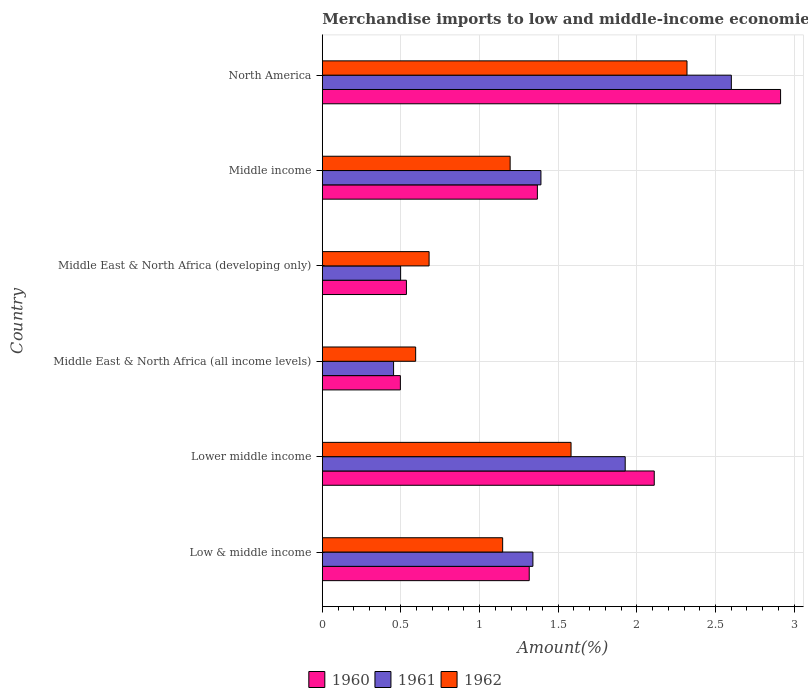How many different coloured bars are there?
Keep it short and to the point. 3. How many groups of bars are there?
Your response must be concise. 6. How many bars are there on the 6th tick from the top?
Keep it short and to the point. 3. How many bars are there on the 2nd tick from the bottom?
Keep it short and to the point. 3. What is the label of the 5th group of bars from the top?
Your answer should be very brief. Lower middle income. What is the percentage of amount earned from merchandise imports in 1960 in Low & middle income?
Make the answer very short. 1.32. Across all countries, what is the maximum percentage of amount earned from merchandise imports in 1961?
Keep it short and to the point. 2.6. Across all countries, what is the minimum percentage of amount earned from merchandise imports in 1961?
Provide a succinct answer. 0.45. In which country was the percentage of amount earned from merchandise imports in 1961 minimum?
Your answer should be very brief. Middle East & North Africa (all income levels). What is the total percentage of amount earned from merchandise imports in 1960 in the graph?
Offer a terse response. 8.74. What is the difference between the percentage of amount earned from merchandise imports in 1960 in Low & middle income and that in Lower middle income?
Keep it short and to the point. -0.79. What is the difference between the percentage of amount earned from merchandise imports in 1962 in Lower middle income and the percentage of amount earned from merchandise imports in 1961 in Low & middle income?
Offer a very short reply. 0.24. What is the average percentage of amount earned from merchandise imports in 1960 per country?
Provide a succinct answer. 1.46. What is the difference between the percentage of amount earned from merchandise imports in 1962 and percentage of amount earned from merchandise imports in 1961 in Middle East & North Africa (developing only)?
Give a very brief answer. 0.18. In how many countries, is the percentage of amount earned from merchandise imports in 1962 greater than 0.6 %?
Keep it short and to the point. 5. What is the ratio of the percentage of amount earned from merchandise imports in 1962 in Lower middle income to that in Middle East & North Africa (all income levels)?
Provide a succinct answer. 2.67. What is the difference between the highest and the second highest percentage of amount earned from merchandise imports in 1960?
Your answer should be very brief. 0.8. What is the difference between the highest and the lowest percentage of amount earned from merchandise imports in 1961?
Keep it short and to the point. 2.15. In how many countries, is the percentage of amount earned from merchandise imports in 1960 greater than the average percentage of amount earned from merchandise imports in 1960 taken over all countries?
Your answer should be compact. 2. Is the sum of the percentage of amount earned from merchandise imports in 1961 in Low & middle income and Lower middle income greater than the maximum percentage of amount earned from merchandise imports in 1960 across all countries?
Ensure brevity in your answer.  Yes. Are all the bars in the graph horizontal?
Give a very brief answer. Yes. Where does the legend appear in the graph?
Ensure brevity in your answer.  Bottom center. How are the legend labels stacked?
Give a very brief answer. Horizontal. What is the title of the graph?
Offer a terse response. Merchandise imports to low and middle-income economies in East Asia & Pacific. What is the label or title of the X-axis?
Your response must be concise. Amount(%). What is the label or title of the Y-axis?
Make the answer very short. Country. What is the Amount(%) of 1960 in Low & middle income?
Provide a succinct answer. 1.32. What is the Amount(%) in 1961 in Low & middle income?
Provide a succinct answer. 1.34. What is the Amount(%) of 1962 in Low & middle income?
Your response must be concise. 1.15. What is the Amount(%) of 1960 in Lower middle income?
Provide a short and direct response. 2.11. What is the Amount(%) of 1961 in Lower middle income?
Your answer should be very brief. 1.93. What is the Amount(%) in 1962 in Lower middle income?
Provide a short and direct response. 1.58. What is the Amount(%) in 1960 in Middle East & North Africa (all income levels)?
Provide a short and direct response. 0.5. What is the Amount(%) in 1961 in Middle East & North Africa (all income levels)?
Keep it short and to the point. 0.45. What is the Amount(%) of 1962 in Middle East & North Africa (all income levels)?
Ensure brevity in your answer.  0.59. What is the Amount(%) of 1960 in Middle East & North Africa (developing only)?
Your response must be concise. 0.53. What is the Amount(%) in 1961 in Middle East & North Africa (developing only)?
Give a very brief answer. 0.5. What is the Amount(%) of 1962 in Middle East & North Africa (developing only)?
Ensure brevity in your answer.  0.68. What is the Amount(%) of 1960 in Middle income?
Provide a short and direct response. 1.37. What is the Amount(%) in 1961 in Middle income?
Your response must be concise. 1.39. What is the Amount(%) in 1962 in Middle income?
Keep it short and to the point. 1.19. What is the Amount(%) in 1960 in North America?
Provide a short and direct response. 2.91. What is the Amount(%) of 1961 in North America?
Keep it short and to the point. 2.6. What is the Amount(%) of 1962 in North America?
Offer a terse response. 2.32. Across all countries, what is the maximum Amount(%) of 1960?
Your response must be concise. 2.91. Across all countries, what is the maximum Amount(%) in 1961?
Provide a short and direct response. 2.6. Across all countries, what is the maximum Amount(%) of 1962?
Give a very brief answer. 2.32. Across all countries, what is the minimum Amount(%) in 1960?
Your answer should be compact. 0.5. Across all countries, what is the minimum Amount(%) of 1961?
Make the answer very short. 0.45. Across all countries, what is the minimum Amount(%) in 1962?
Provide a succinct answer. 0.59. What is the total Amount(%) in 1960 in the graph?
Provide a succinct answer. 8.74. What is the total Amount(%) in 1961 in the graph?
Make the answer very short. 8.21. What is the total Amount(%) in 1962 in the graph?
Provide a short and direct response. 7.51. What is the difference between the Amount(%) of 1960 in Low & middle income and that in Lower middle income?
Your answer should be compact. -0.8. What is the difference between the Amount(%) of 1961 in Low & middle income and that in Lower middle income?
Make the answer very short. -0.59. What is the difference between the Amount(%) in 1962 in Low & middle income and that in Lower middle income?
Offer a terse response. -0.43. What is the difference between the Amount(%) of 1960 in Low & middle income and that in Middle East & North Africa (all income levels)?
Keep it short and to the point. 0.82. What is the difference between the Amount(%) in 1961 in Low & middle income and that in Middle East & North Africa (all income levels)?
Ensure brevity in your answer.  0.89. What is the difference between the Amount(%) of 1962 in Low & middle income and that in Middle East & North Africa (all income levels)?
Your response must be concise. 0.55. What is the difference between the Amount(%) in 1960 in Low & middle income and that in Middle East & North Africa (developing only)?
Provide a short and direct response. 0.78. What is the difference between the Amount(%) in 1961 in Low & middle income and that in Middle East & North Africa (developing only)?
Ensure brevity in your answer.  0.84. What is the difference between the Amount(%) of 1962 in Low & middle income and that in Middle East & North Africa (developing only)?
Ensure brevity in your answer.  0.47. What is the difference between the Amount(%) in 1960 in Low & middle income and that in Middle income?
Your answer should be compact. -0.05. What is the difference between the Amount(%) in 1961 in Low & middle income and that in Middle income?
Offer a very short reply. -0.05. What is the difference between the Amount(%) of 1962 in Low & middle income and that in Middle income?
Your response must be concise. -0.05. What is the difference between the Amount(%) in 1960 in Low & middle income and that in North America?
Give a very brief answer. -1.6. What is the difference between the Amount(%) of 1961 in Low & middle income and that in North America?
Offer a very short reply. -1.26. What is the difference between the Amount(%) of 1962 in Low & middle income and that in North America?
Give a very brief answer. -1.17. What is the difference between the Amount(%) of 1960 in Lower middle income and that in Middle East & North Africa (all income levels)?
Provide a short and direct response. 1.61. What is the difference between the Amount(%) of 1961 in Lower middle income and that in Middle East & North Africa (all income levels)?
Offer a terse response. 1.47. What is the difference between the Amount(%) of 1962 in Lower middle income and that in Middle East & North Africa (all income levels)?
Offer a very short reply. 0.99. What is the difference between the Amount(%) in 1960 in Lower middle income and that in Middle East & North Africa (developing only)?
Your answer should be compact. 1.58. What is the difference between the Amount(%) in 1961 in Lower middle income and that in Middle East & North Africa (developing only)?
Make the answer very short. 1.43. What is the difference between the Amount(%) in 1962 in Lower middle income and that in Middle East & North Africa (developing only)?
Give a very brief answer. 0.9. What is the difference between the Amount(%) in 1960 in Lower middle income and that in Middle income?
Provide a short and direct response. 0.74. What is the difference between the Amount(%) of 1961 in Lower middle income and that in Middle income?
Offer a very short reply. 0.54. What is the difference between the Amount(%) of 1962 in Lower middle income and that in Middle income?
Offer a terse response. 0.39. What is the difference between the Amount(%) of 1960 in Lower middle income and that in North America?
Your answer should be compact. -0.8. What is the difference between the Amount(%) in 1961 in Lower middle income and that in North America?
Provide a succinct answer. -0.67. What is the difference between the Amount(%) in 1962 in Lower middle income and that in North America?
Offer a very short reply. -0.74. What is the difference between the Amount(%) in 1960 in Middle East & North Africa (all income levels) and that in Middle East & North Africa (developing only)?
Keep it short and to the point. -0.04. What is the difference between the Amount(%) in 1961 in Middle East & North Africa (all income levels) and that in Middle East & North Africa (developing only)?
Offer a very short reply. -0.04. What is the difference between the Amount(%) in 1962 in Middle East & North Africa (all income levels) and that in Middle East & North Africa (developing only)?
Offer a terse response. -0.09. What is the difference between the Amount(%) in 1960 in Middle East & North Africa (all income levels) and that in Middle income?
Offer a terse response. -0.87. What is the difference between the Amount(%) in 1961 in Middle East & North Africa (all income levels) and that in Middle income?
Provide a short and direct response. -0.94. What is the difference between the Amount(%) in 1962 in Middle East & North Africa (all income levels) and that in Middle income?
Your answer should be very brief. -0.6. What is the difference between the Amount(%) in 1960 in Middle East & North Africa (all income levels) and that in North America?
Offer a terse response. -2.42. What is the difference between the Amount(%) of 1961 in Middle East & North Africa (all income levels) and that in North America?
Give a very brief answer. -2.15. What is the difference between the Amount(%) of 1962 in Middle East & North Africa (all income levels) and that in North America?
Your answer should be compact. -1.73. What is the difference between the Amount(%) of 1960 in Middle East & North Africa (developing only) and that in Middle income?
Provide a succinct answer. -0.83. What is the difference between the Amount(%) in 1961 in Middle East & North Africa (developing only) and that in Middle income?
Ensure brevity in your answer.  -0.89. What is the difference between the Amount(%) in 1962 in Middle East & North Africa (developing only) and that in Middle income?
Keep it short and to the point. -0.52. What is the difference between the Amount(%) in 1960 in Middle East & North Africa (developing only) and that in North America?
Your answer should be very brief. -2.38. What is the difference between the Amount(%) of 1961 in Middle East & North Africa (developing only) and that in North America?
Keep it short and to the point. -2.1. What is the difference between the Amount(%) in 1962 in Middle East & North Africa (developing only) and that in North America?
Your response must be concise. -1.64. What is the difference between the Amount(%) in 1960 in Middle income and that in North America?
Give a very brief answer. -1.55. What is the difference between the Amount(%) in 1961 in Middle income and that in North America?
Provide a short and direct response. -1.21. What is the difference between the Amount(%) of 1962 in Middle income and that in North America?
Offer a terse response. -1.12. What is the difference between the Amount(%) of 1960 in Low & middle income and the Amount(%) of 1961 in Lower middle income?
Keep it short and to the point. -0.61. What is the difference between the Amount(%) in 1960 in Low & middle income and the Amount(%) in 1962 in Lower middle income?
Ensure brevity in your answer.  -0.27. What is the difference between the Amount(%) in 1961 in Low & middle income and the Amount(%) in 1962 in Lower middle income?
Make the answer very short. -0.24. What is the difference between the Amount(%) of 1960 in Low & middle income and the Amount(%) of 1961 in Middle East & North Africa (all income levels)?
Your answer should be very brief. 0.86. What is the difference between the Amount(%) of 1960 in Low & middle income and the Amount(%) of 1962 in Middle East & North Africa (all income levels)?
Keep it short and to the point. 0.72. What is the difference between the Amount(%) of 1961 in Low & middle income and the Amount(%) of 1962 in Middle East & North Africa (all income levels)?
Give a very brief answer. 0.75. What is the difference between the Amount(%) of 1960 in Low & middle income and the Amount(%) of 1961 in Middle East & North Africa (developing only)?
Your response must be concise. 0.82. What is the difference between the Amount(%) of 1960 in Low & middle income and the Amount(%) of 1962 in Middle East & North Africa (developing only)?
Your answer should be compact. 0.64. What is the difference between the Amount(%) in 1961 in Low & middle income and the Amount(%) in 1962 in Middle East & North Africa (developing only)?
Provide a succinct answer. 0.66. What is the difference between the Amount(%) of 1960 in Low & middle income and the Amount(%) of 1961 in Middle income?
Your response must be concise. -0.07. What is the difference between the Amount(%) in 1960 in Low & middle income and the Amount(%) in 1962 in Middle income?
Your answer should be very brief. 0.12. What is the difference between the Amount(%) of 1961 in Low & middle income and the Amount(%) of 1962 in Middle income?
Make the answer very short. 0.14. What is the difference between the Amount(%) in 1960 in Low & middle income and the Amount(%) in 1961 in North America?
Offer a terse response. -1.29. What is the difference between the Amount(%) in 1960 in Low & middle income and the Amount(%) in 1962 in North America?
Provide a succinct answer. -1. What is the difference between the Amount(%) in 1961 in Low & middle income and the Amount(%) in 1962 in North America?
Offer a very short reply. -0.98. What is the difference between the Amount(%) in 1960 in Lower middle income and the Amount(%) in 1961 in Middle East & North Africa (all income levels)?
Give a very brief answer. 1.66. What is the difference between the Amount(%) of 1960 in Lower middle income and the Amount(%) of 1962 in Middle East & North Africa (all income levels)?
Keep it short and to the point. 1.52. What is the difference between the Amount(%) in 1961 in Lower middle income and the Amount(%) in 1962 in Middle East & North Africa (all income levels)?
Your answer should be very brief. 1.33. What is the difference between the Amount(%) of 1960 in Lower middle income and the Amount(%) of 1961 in Middle East & North Africa (developing only)?
Your response must be concise. 1.61. What is the difference between the Amount(%) of 1960 in Lower middle income and the Amount(%) of 1962 in Middle East & North Africa (developing only)?
Keep it short and to the point. 1.43. What is the difference between the Amount(%) of 1961 in Lower middle income and the Amount(%) of 1962 in Middle East & North Africa (developing only)?
Your response must be concise. 1.25. What is the difference between the Amount(%) of 1960 in Lower middle income and the Amount(%) of 1961 in Middle income?
Provide a short and direct response. 0.72. What is the difference between the Amount(%) in 1960 in Lower middle income and the Amount(%) in 1962 in Middle income?
Provide a succinct answer. 0.92. What is the difference between the Amount(%) in 1961 in Lower middle income and the Amount(%) in 1962 in Middle income?
Keep it short and to the point. 0.73. What is the difference between the Amount(%) in 1960 in Lower middle income and the Amount(%) in 1961 in North America?
Your response must be concise. -0.49. What is the difference between the Amount(%) of 1960 in Lower middle income and the Amount(%) of 1962 in North America?
Make the answer very short. -0.21. What is the difference between the Amount(%) of 1961 in Lower middle income and the Amount(%) of 1962 in North America?
Offer a terse response. -0.39. What is the difference between the Amount(%) in 1960 in Middle East & North Africa (all income levels) and the Amount(%) in 1961 in Middle East & North Africa (developing only)?
Keep it short and to the point. -0. What is the difference between the Amount(%) in 1960 in Middle East & North Africa (all income levels) and the Amount(%) in 1962 in Middle East & North Africa (developing only)?
Provide a succinct answer. -0.18. What is the difference between the Amount(%) in 1961 in Middle East & North Africa (all income levels) and the Amount(%) in 1962 in Middle East & North Africa (developing only)?
Provide a succinct answer. -0.23. What is the difference between the Amount(%) of 1960 in Middle East & North Africa (all income levels) and the Amount(%) of 1961 in Middle income?
Your answer should be compact. -0.89. What is the difference between the Amount(%) in 1960 in Middle East & North Africa (all income levels) and the Amount(%) in 1962 in Middle income?
Your answer should be very brief. -0.7. What is the difference between the Amount(%) of 1961 in Middle East & North Africa (all income levels) and the Amount(%) of 1962 in Middle income?
Provide a short and direct response. -0.74. What is the difference between the Amount(%) of 1960 in Middle East & North Africa (all income levels) and the Amount(%) of 1961 in North America?
Ensure brevity in your answer.  -2.1. What is the difference between the Amount(%) of 1960 in Middle East & North Africa (all income levels) and the Amount(%) of 1962 in North America?
Provide a short and direct response. -1.82. What is the difference between the Amount(%) of 1961 in Middle East & North Africa (all income levels) and the Amount(%) of 1962 in North America?
Your response must be concise. -1.87. What is the difference between the Amount(%) in 1960 in Middle East & North Africa (developing only) and the Amount(%) in 1961 in Middle income?
Offer a terse response. -0.86. What is the difference between the Amount(%) in 1960 in Middle East & North Africa (developing only) and the Amount(%) in 1962 in Middle income?
Offer a very short reply. -0.66. What is the difference between the Amount(%) of 1961 in Middle East & North Africa (developing only) and the Amount(%) of 1962 in Middle income?
Give a very brief answer. -0.7. What is the difference between the Amount(%) in 1960 in Middle East & North Africa (developing only) and the Amount(%) in 1961 in North America?
Offer a very short reply. -2.07. What is the difference between the Amount(%) in 1960 in Middle East & North Africa (developing only) and the Amount(%) in 1962 in North America?
Keep it short and to the point. -1.78. What is the difference between the Amount(%) in 1961 in Middle East & North Africa (developing only) and the Amount(%) in 1962 in North America?
Your response must be concise. -1.82. What is the difference between the Amount(%) in 1960 in Middle income and the Amount(%) in 1961 in North America?
Keep it short and to the point. -1.23. What is the difference between the Amount(%) in 1960 in Middle income and the Amount(%) in 1962 in North America?
Your response must be concise. -0.95. What is the difference between the Amount(%) in 1961 in Middle income and the Amount(%) in 1962 in North America?
Provide a short and direct response. -0.93. What is the average Amount(%) in 1960 per country?
Make the answer very short. 1.46. What is the average Amount(%) in 1961 per country?
Keep it short and to the point. 1.37. What is the average Amount(%) in 1962 per country?
Provide a succinct answer. 1.25. What is the difference between the Amount(%) of 1960 and Amount(%) of 1961 in Low & middle income?
Offer a terse response. -0.02. What is the difference between the Amount(%) in 1960 and Amount(%) in 1962 in Low & middle income?
Your answer should be compact. 0.17. What is the difference between the Amount(%) in 1961 and Amount(%) in 1962 in Low & middle income?
Your answer should be compact. 0.19. What is the difference between the Amount(%) of 1960 and Amount(%) of 1961 in Lower middle income?
Make the answer very short. 0.18. What is the difference between the Amount(%) of 1960 and Amount(%) of 1962 in Lower middle income?
Ensure brevity in your answer.  0.53. What is the difference between the Amount(%) of 1961 and Amount(%) of 1962 in Lower middle income?
Your answer should be compact. 0.34. What is the difference between the Amount(%) in 1960 and Amount(%) in 1961 in Middle East & North Africa (all income levels)?
Give a very brief answer. 0.04. What is the difference between the Amount(%) of 1960 and Amount(%) of 1962 in Middle East & North Africa (all income levels)?
Provide a succinct answer. -0.1. What is the difference between the Amount(%) of 1961 and Amount(%) of 1962 in Middle East & North Africa (all income levels)?
Provide a short and direct response. -0.14. What is the difference between the Amount(%) of 1960 and Amount(%) of 1961 in Middle East & North Africa (developing only)?
Your answer should be compact. 0.04. What is the difference between the Amount(%) of 1960 and Amount(%) of 1962 in Middle East & North Africa (developing only)?
Provide a short and direct response. -0.14. What is the difference between the Amount(%) in 1961 and Amount(%) in 1962 in Middle East & North Africa (developing only)?
Provide a succinct answer. -0.18. What is the difference between the Amount(%) in 1960 and Amount(%) in 1961 in Middle income?
Ensure brevity in your answer.  -0.02. What is the difference between the Amount(%) of 1960 and Amount(%) of 1962 in Middle income?
Give a very brief answer. 0.17. What is the difference between the Amount(%) of 1961 and Amount(%) of 1962 in Middle income?
Your answer should be very brief. 0.2. What is the difference between the Amount(%) in 1960 and Amount(%) in 1961 in North America?
Ensure brevity in your answer.  0.31. What is the difference between the Amount(%) in 1960 and Amount(%) in 1962 in North America?
Ensure brevity in your answer.  0.6. What is the difference between the Amount(%) in 1961 and Amount(%) in 1962 in North America?
Ensure brevity in your answer.  0.28. What is the ratio of the Amount(%) in 1960 in Low & middle income to that in Lower middle income?
Provide a succinct answer. 0.62. What is the ratio of the Amount(%) in 1961 in Low & middle income to that in Lower middle income?
Offer a very short reply. 0.7. What is the ratio of the Amount(%) in 1962 in Low & middle income to that in Lower middle income?
Ensure brevity in your answer.  0.73. What is the ratio of the Amount(%) of 1960 in Low & middle income to that in Middle East & North Africa (all income levels)?
Your response must be concise. 2.65. What is the ratio of the Amount(%) of 1961 in Low & middle income to that in Middle East & North Africa (all income levels)?
Ensure brevity in your answer.  2.96. What is the ratio of the Amount(%) of 1962 in Low & middle income to that in Middle East & North Africa (all income levels)?
Provide a succinct answer. 1.93. What is the ratio of the Amount(%) of 1960 in Low & middle income to that in Middle East & North Africa (developing only)?
Keep it short and to the point. 2.46. What is the ratio of the Amount(%) of 1961 in Low & middle income to that in Middle East & North Africa (developing only)?
Offer a terse response. 2.69. What is the ratio of the Amount(%) in 1962 in Low & middle income to that in Middle East & North Africa (developing only)?
Ensure brevity in your answer.  1.69. What is the ratio of the Amount(%) of 1960 in Low & middle income to that in Middle income?
Give a very brief answer. 0.96. What is the ratio of the Amount(%) of 1961 in Low & middle income to that in Middle income?
Your response must be concise. 0.96. What is the ratio of the Amount(%) of 1962 in Low & middle income to that in Middle income?
Your answer should be very brief. 0.96. What is the ratio of the Amount(%) of 1960 in Low & middle income to that in North America?
Your answer should be compact. 0.45. What is the ratio of the Amount(%) in 1961 in Low & middle income to that in North America?
Ensure brevity in your answer.  0.51. What is the ratio of the Amount(%) in 1962 in Low & middle income to that in North America?
Ensure brevity in your answer.  0.49. What is the ratio of the Amount(%) in 1960 in Lower middle income to that in Middle East & North Africa (all income levels)?
Your response must be concise. 4.25. What is the ratio of the Amount(%) of 1961 in Lower middle income to that in Middle East & North Africa (all income levels)?
Offer a very short reply. 4.25. What is the ratio of the Amount(%) in 1962 in Lower middle income to that in Middle East & North Africa (all income levels)?
Your answer should be compact. 2.67. What is the ratio of the Amount(%) in 1960 in Lower middle income to that in Middle East & North Africa (developing only)?
Your answer should be very brief. 3.95. What is the ratio of the Amount(%) in 1961 in Lower middle income to that in Middle East & North Africa (developing only)?
Your answer should be very brief. 3.87. What is the ratio of the Amount(%) in 1962 in Lower middle income to that in Middle East & North Africa (developing only)?
Provide a short and direct response. 2.33. What is the ratio of the Amount(%) in 1960 in Lower middle income to that in Middle income?
Offer a very short reply. 1.54. What is the ratio of the Amount(%) in 1961 in Lower middle income to that in Middle income?
Your answer should be compact. 1.39. What is the ratio of the Amount(%) in 1962 in Lower middle income to that in Middle income?
Offer a very short reply. 1.32. What is the ratio of the Amount(%) in 1960 in Lower middle income to that in North America?
Your answer should be compact. 0.72. What is the ratio of the Amount(%) of 1961 in Lower middle income to that in North America?
Your answer should be compact. 0.74. What is the ratio of the Amount(%) of 1962 in Lower middle income to that in North America?
Offer a very short reply. 0.68. What is the ratio of the Amount(%) of 1960 in Middle East & North Africa (all income levels) to that in Middle East & North Africa (developing only)?
Your answer should be compact. 0.93. What is the ratio of the Amount(%) in 1961 in Middle East & North Africa (all income levels) to that in Middle East & North Africa (developing only)?
Provide a short and direct response. 0.91. What is the ratio of the Amount(%) of 1962 in Middle East & North Africa (all income levels) to that in Middle East & North Africa (developing only)?
Give a very brief answer. 0.87. What is the ratio of the Amount(%) in 1960 in Middle East & North Africa (all income levels) to that in Middle income?
Your answer should be very brief. 0.36. What is the ratio of the Amount(%) of 1961 in Middle East & North Africa (all income levels) to that in Middle income?
Provide a short and direct response. 0.33. What is the ratio of the Amount(%) of 1962 in Middle East & North Africa (all income levels) to that in Middle income?
Keep it short and to the point. 0.5. What is the ratio of the Amount(%) of 1960 in Middle East & North Africa (all income levels) to that in North America?
Provide a succinct answer. 0.17. What is the ratio of the Amount(%) in 1961 in Middle East & North Africa (all income levels) to that in North America?
Your answer should be very brief. 0.17. What is the ratio of the Amount(%) in 1962 in Middle East & North Africa (all income levels) to that in North America?
Offer a terse response. 0.26. What is the ratio of the Amount(%) in 1960 in Middle East & North Africa (developing only) to that in Middle income?
Make the answer very short. 0.39. What is the ratio of the Amount(%) in 1961 in Middle East & North Africa (developing only) to that in Middle income?
Your answer should be very brief. 0.36. What is the ratio of the Amount(%) in 1962 in Middle East & North Africa (developing only) to that in Middle income?
Offer a very short reply. 0.57. What is the ratio of the Amount(%) in 1960 in Middle East & North Africa (developing only) to that in North America?
Your response must be concise. 0.18. What is the ratio of the Amount(%) in 1961 in Middle East & North Africa (developing only) to that in North America?
Give a very brief answer. 0.19. What is the ratio of the Amount(%) in 1962 in Middle East & North Africa (developing only) to that in North America?
Ensure brevity in your answer.  0.29. What is the ratio of the Amount(%) of 1960 in Middle income to that in North America?
Offer a very short reply. 0.47. What is the ratio of the Amount(%) in 1961 in Middle income to that in North America?
Provide a short and direct response. 0.53. What is the ratio of the Amount(%) of 1962 in Middle income to that in North America?
Your answer should be compact. 0.52. What is the difference between the highest and the second highest Amount(%) of 1960?
Ensure brevity in your answer.  0.8. What is the difference between the highest and the second highest Amount(%) in 1961?
Give a very brief answer. 0.67. What is the difference between the highest and the second highest Amount(%) in 1962?
Your answer should be compact. 0.74. What is the difference between the highest and the lowest Amount(%) in 1960?
Give a very brief answer. 2.42. What is the difference between the highest and the lowest Amount(%) of 1961?
Provide a short and direct response. 2.15. What is the difference between the highest and the lowest Amount(%) of 1962?
Your response must be concise. 1.73. 